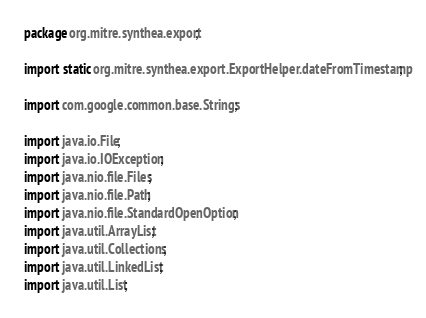<code> <loc_0><loc_0><loc_500><loc_500><_Java_>package org.mitre.synthea.export;

import static org.mitre.synthea.export.ExportHelper.dateFromTimestamp;

import com.google.common.base.Strings;

import java.io.File;
import java.io.IOException;
import java.nio.file.Files;
import java.nio.file.Path;
import java.nio.file.StandardOpenOption;
import java.util.ArrayList;
import java.util.Collections;
import java.util.LinkedList;
import java.util.List;
</code> 